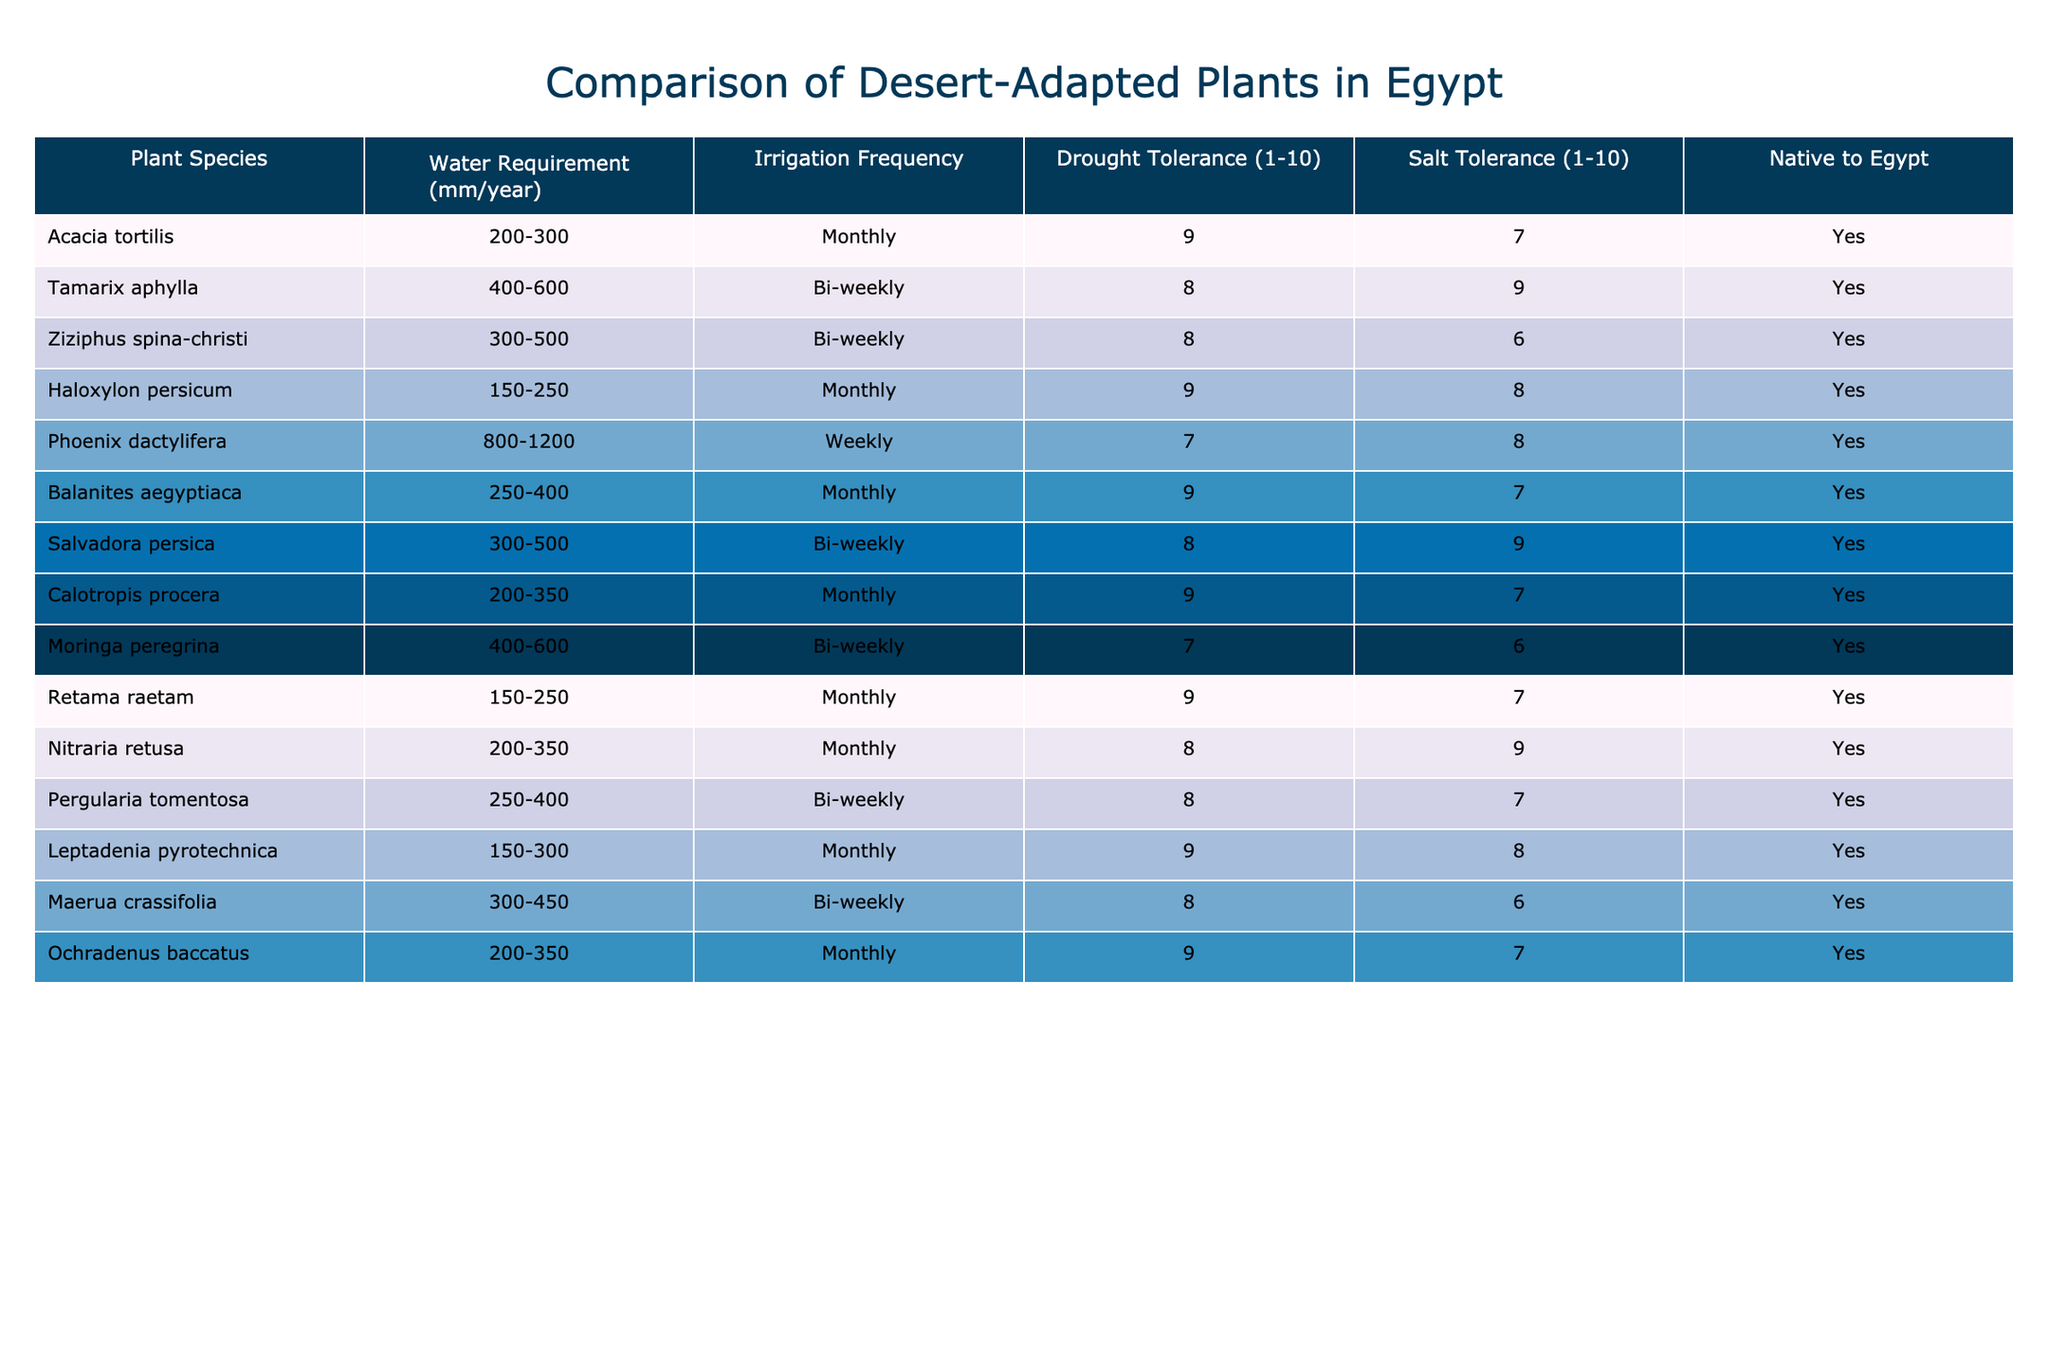What is the water requirement range of Acacia tortilis? The table directly states the water requirement for Acacia tortilis as 200-300 mm/year.
Answer: 200-300 mm/year Which plant has the highest water requirement? By comparing the water requirements listed in mm/year, Phoenix dactylifera has the highest range of 800-1200 mm/year.
Answer: Phoenix dactylifera How many plants have a drought tolerance rating of 9? By reviewing the drought tolerance column, Acacia tortilis, Haloxylon persicum, Balanites aegyptiaca, Calotropis procera, Retama raetam, and Ochradenus baccatus all have a drought tolerance rating of 9, totaling 6 plants.
Answer: 6 plants What is the average water requirement of the plants native to Egypt? First, we take note of the water requirement ranges and convert them to a common format (averaging the min and max). Then, summing up the averages: (250 + 100 + 300 + 200 + 1000 + 325 + 400 + 275 + 500 + 150 + 275 + 233.5 + 200 + 300 + 300) / 14 = 343.5 mm/year approximately.
Answer: 343.5 mm/year Is the salt tolerance of Ziziphus spina-christi greater than that of Tamarix aphylla? A direct comparison of the salt tolerance ratings shows Ziziphus spina-christi has a rating of 6, while Tamarix aphylla has a rating of 9. Therefore, Ziziphus spina-christi has lower salt tolerance.
Answer: No 